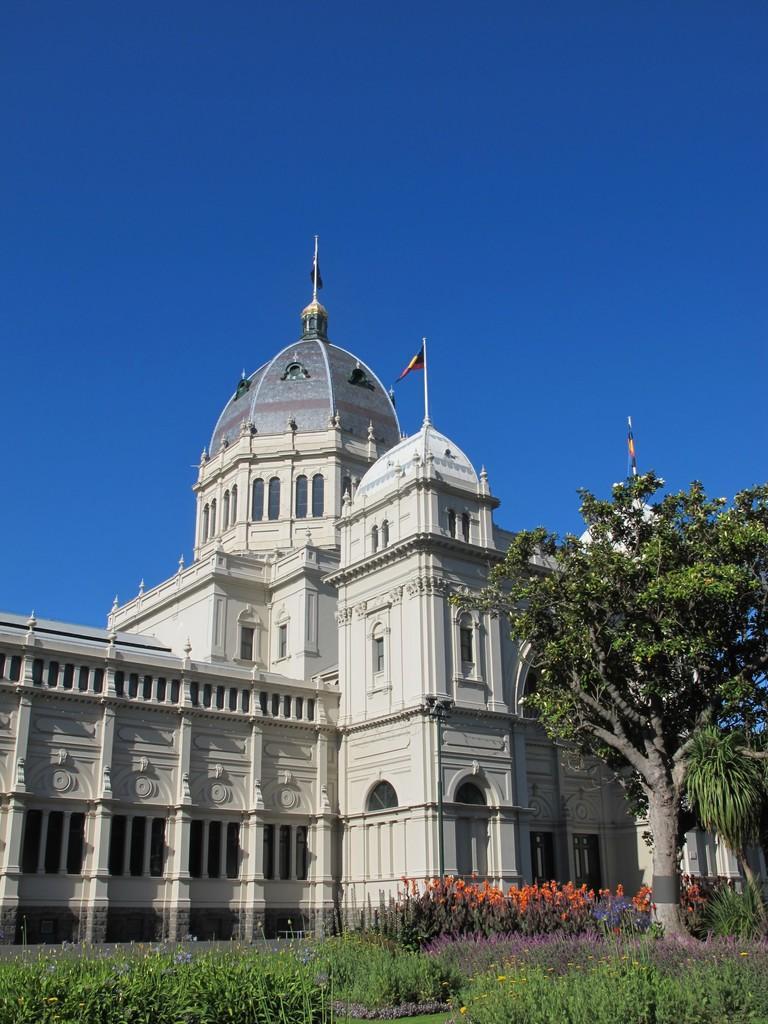Could you give a brief overview of what you see in this image? At the bottom of this image, there are plants, trees and grass on the ground. In the background, there is a building, which is having windows, flags arranged on the top and there is blue sky. 